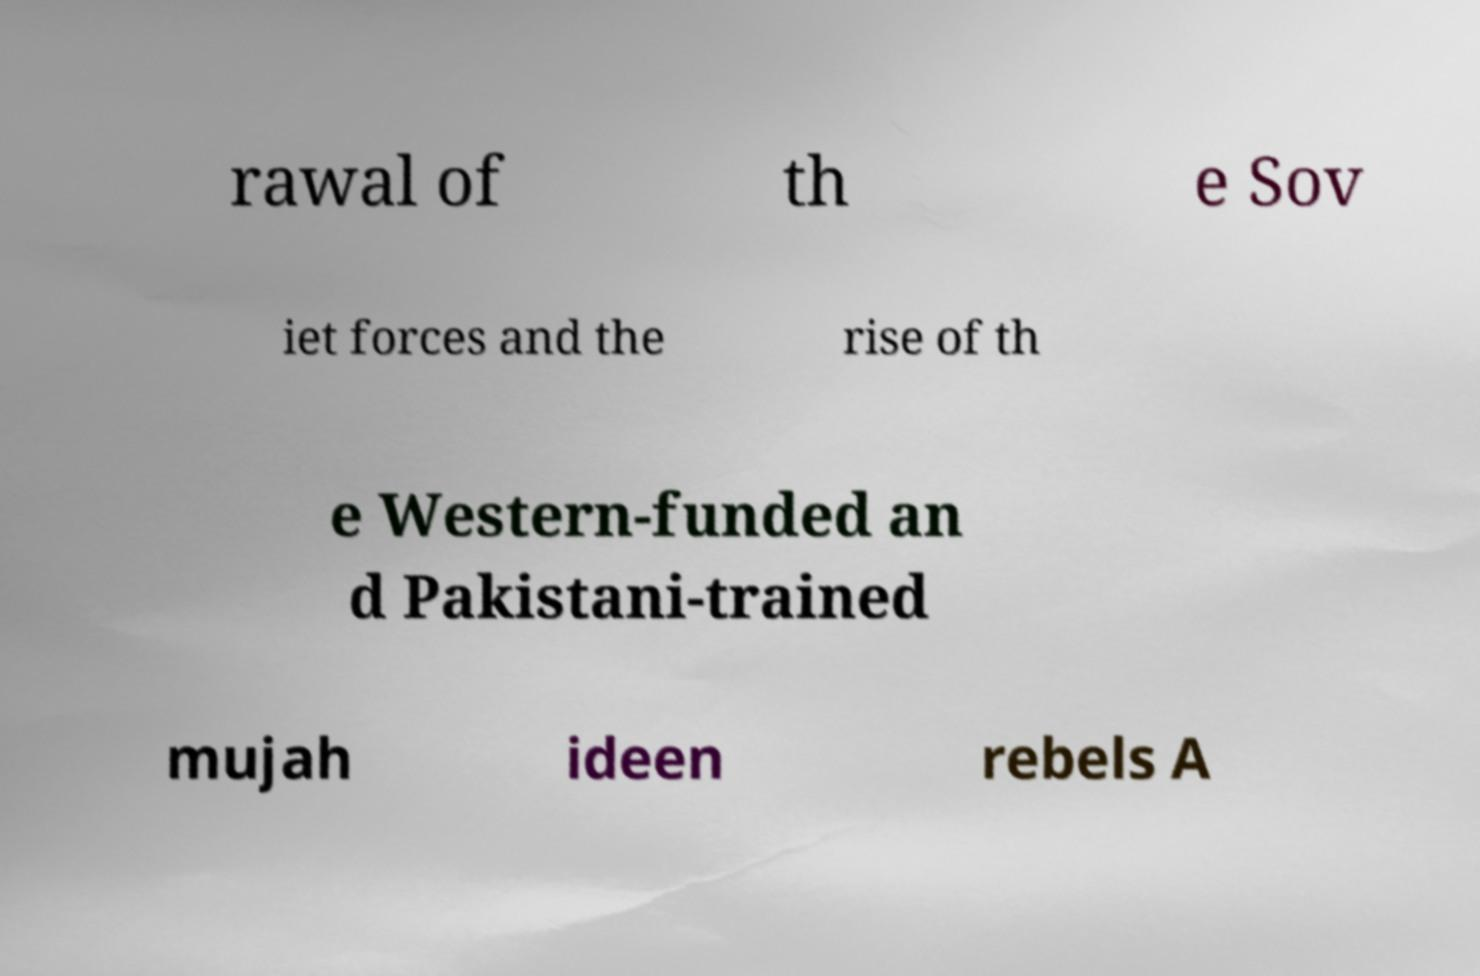What messages or text are displayed in this image? I need them in a readable, typed format. rawal of th e Sov iet forces and the rise of th e Western-funded an d Pakistani-trained mujah ideen rebels A 